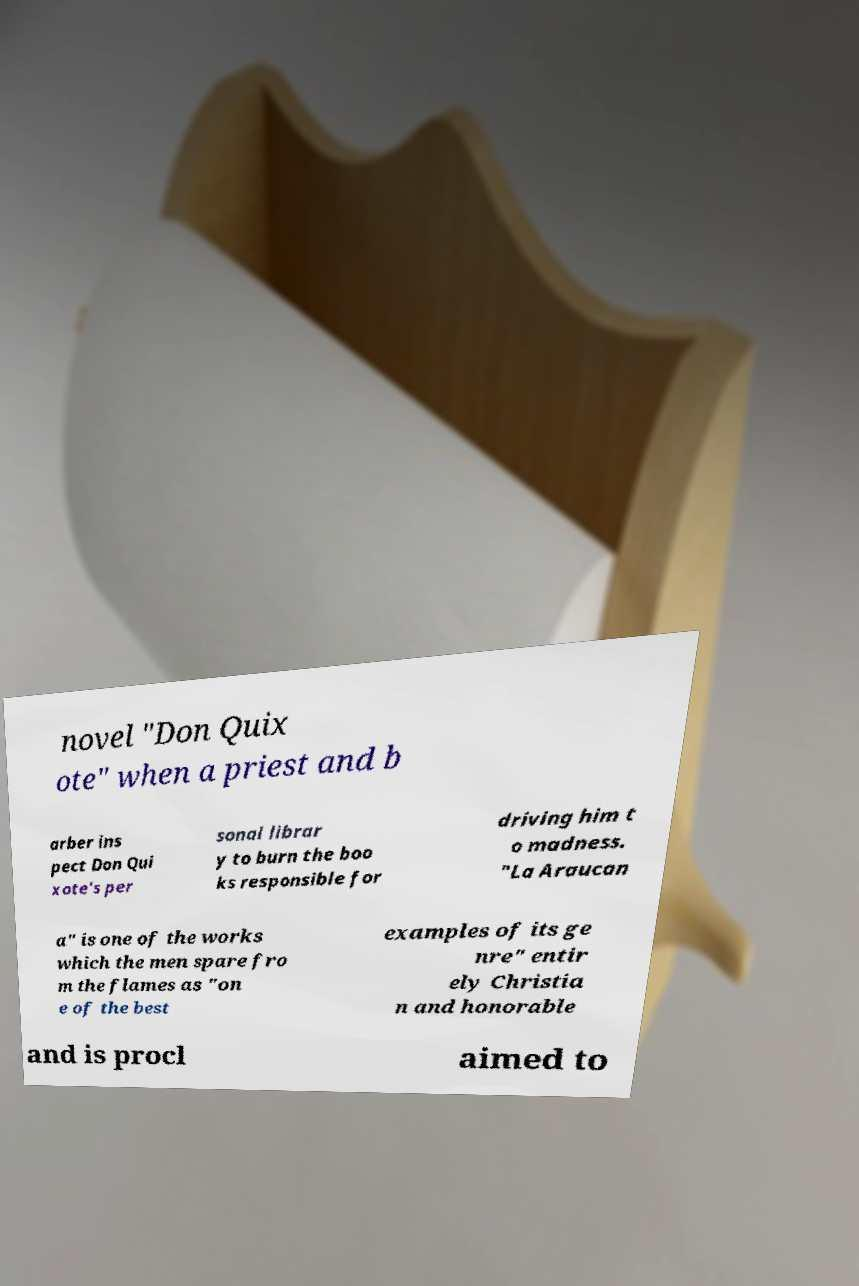There's text embedded in this image that I need extracted. Can you transcribe it verbatim? novel "Don Quix ote" when a priest and b arber ins pect Don Qui xote's per sonal librar y to burn the boo ks responsible for driving him t o madness. "La Araucan a" is one of the works which the men spare fro m the flames as "on e of the best examples of its ge nre" entir ely Christia n and honorable and is procl aimed to 